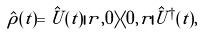<formula> <loc_0><loc_0><loc_500><loc_500>\hat { \rho } ( t ) = \hat { U } ( t ) | r , 0 \rangle \langle 0 , r | \hat { U } ^ { \dagger } ( t ) ,</formula> 